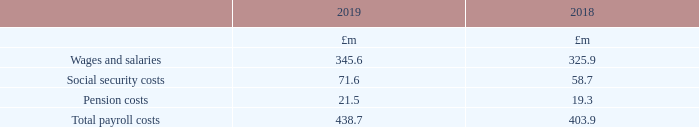5 Staff costs and numbers
The aggregate payroll costs of persons employed by the Group were as follows:
What information does the table provide? The aggregate payroll costs of persons employed by the group. What was the total payroll costs in 2018?
Answer scale should be: million. 403.9. What are the different components that make up the total payroll costs? Wages and salaries, social security costs, pension costs. In which year was the amount of wages and salaries larger? 345.6>325.9
Answer: 2019. What was the change in social security costs in 2019 from 2018?
Answer scale should be: million. 71.6-58.7
Answer: 12.9. What was the percentage change in social security costs in 2019 from 2018?
Answer scale should be: percent. (71.6-58.7)/58.7
Answer: 21.98. 